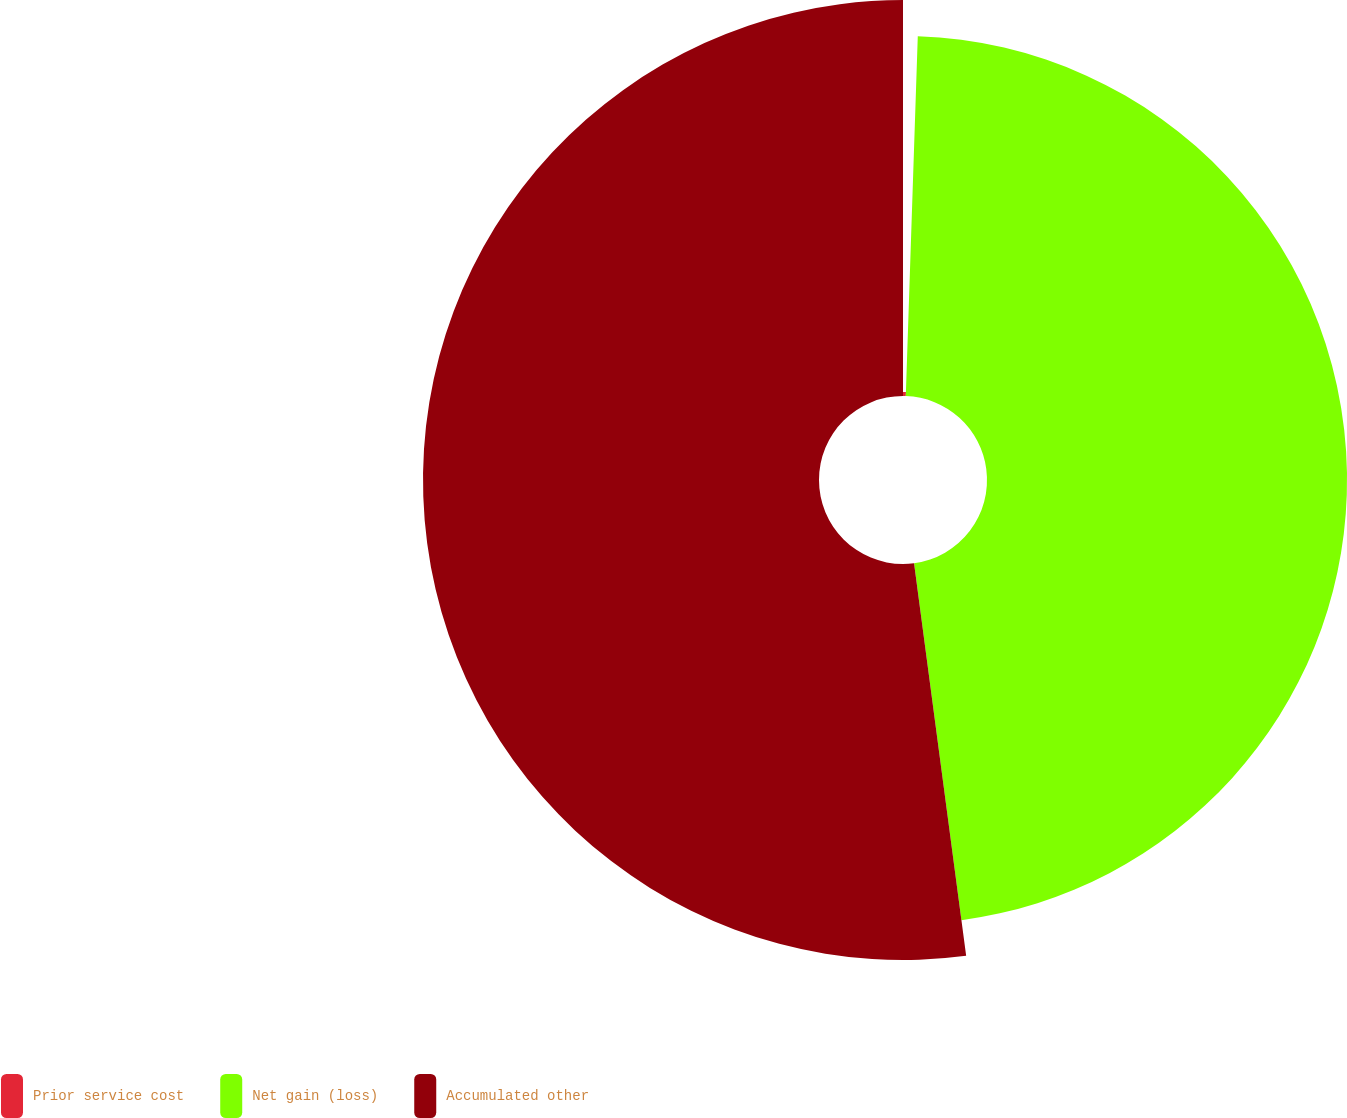Convert chart to OTSL. <chart><loc_0><loc_0><loc_500><loc_500><pie_chart><fcel>Prior service cost<fcel>Net gain (loss)<fcel>Accumulated other<nl><fcel>0.53%<fcel>47.37%<fcel>52.1%<nl></chart> 